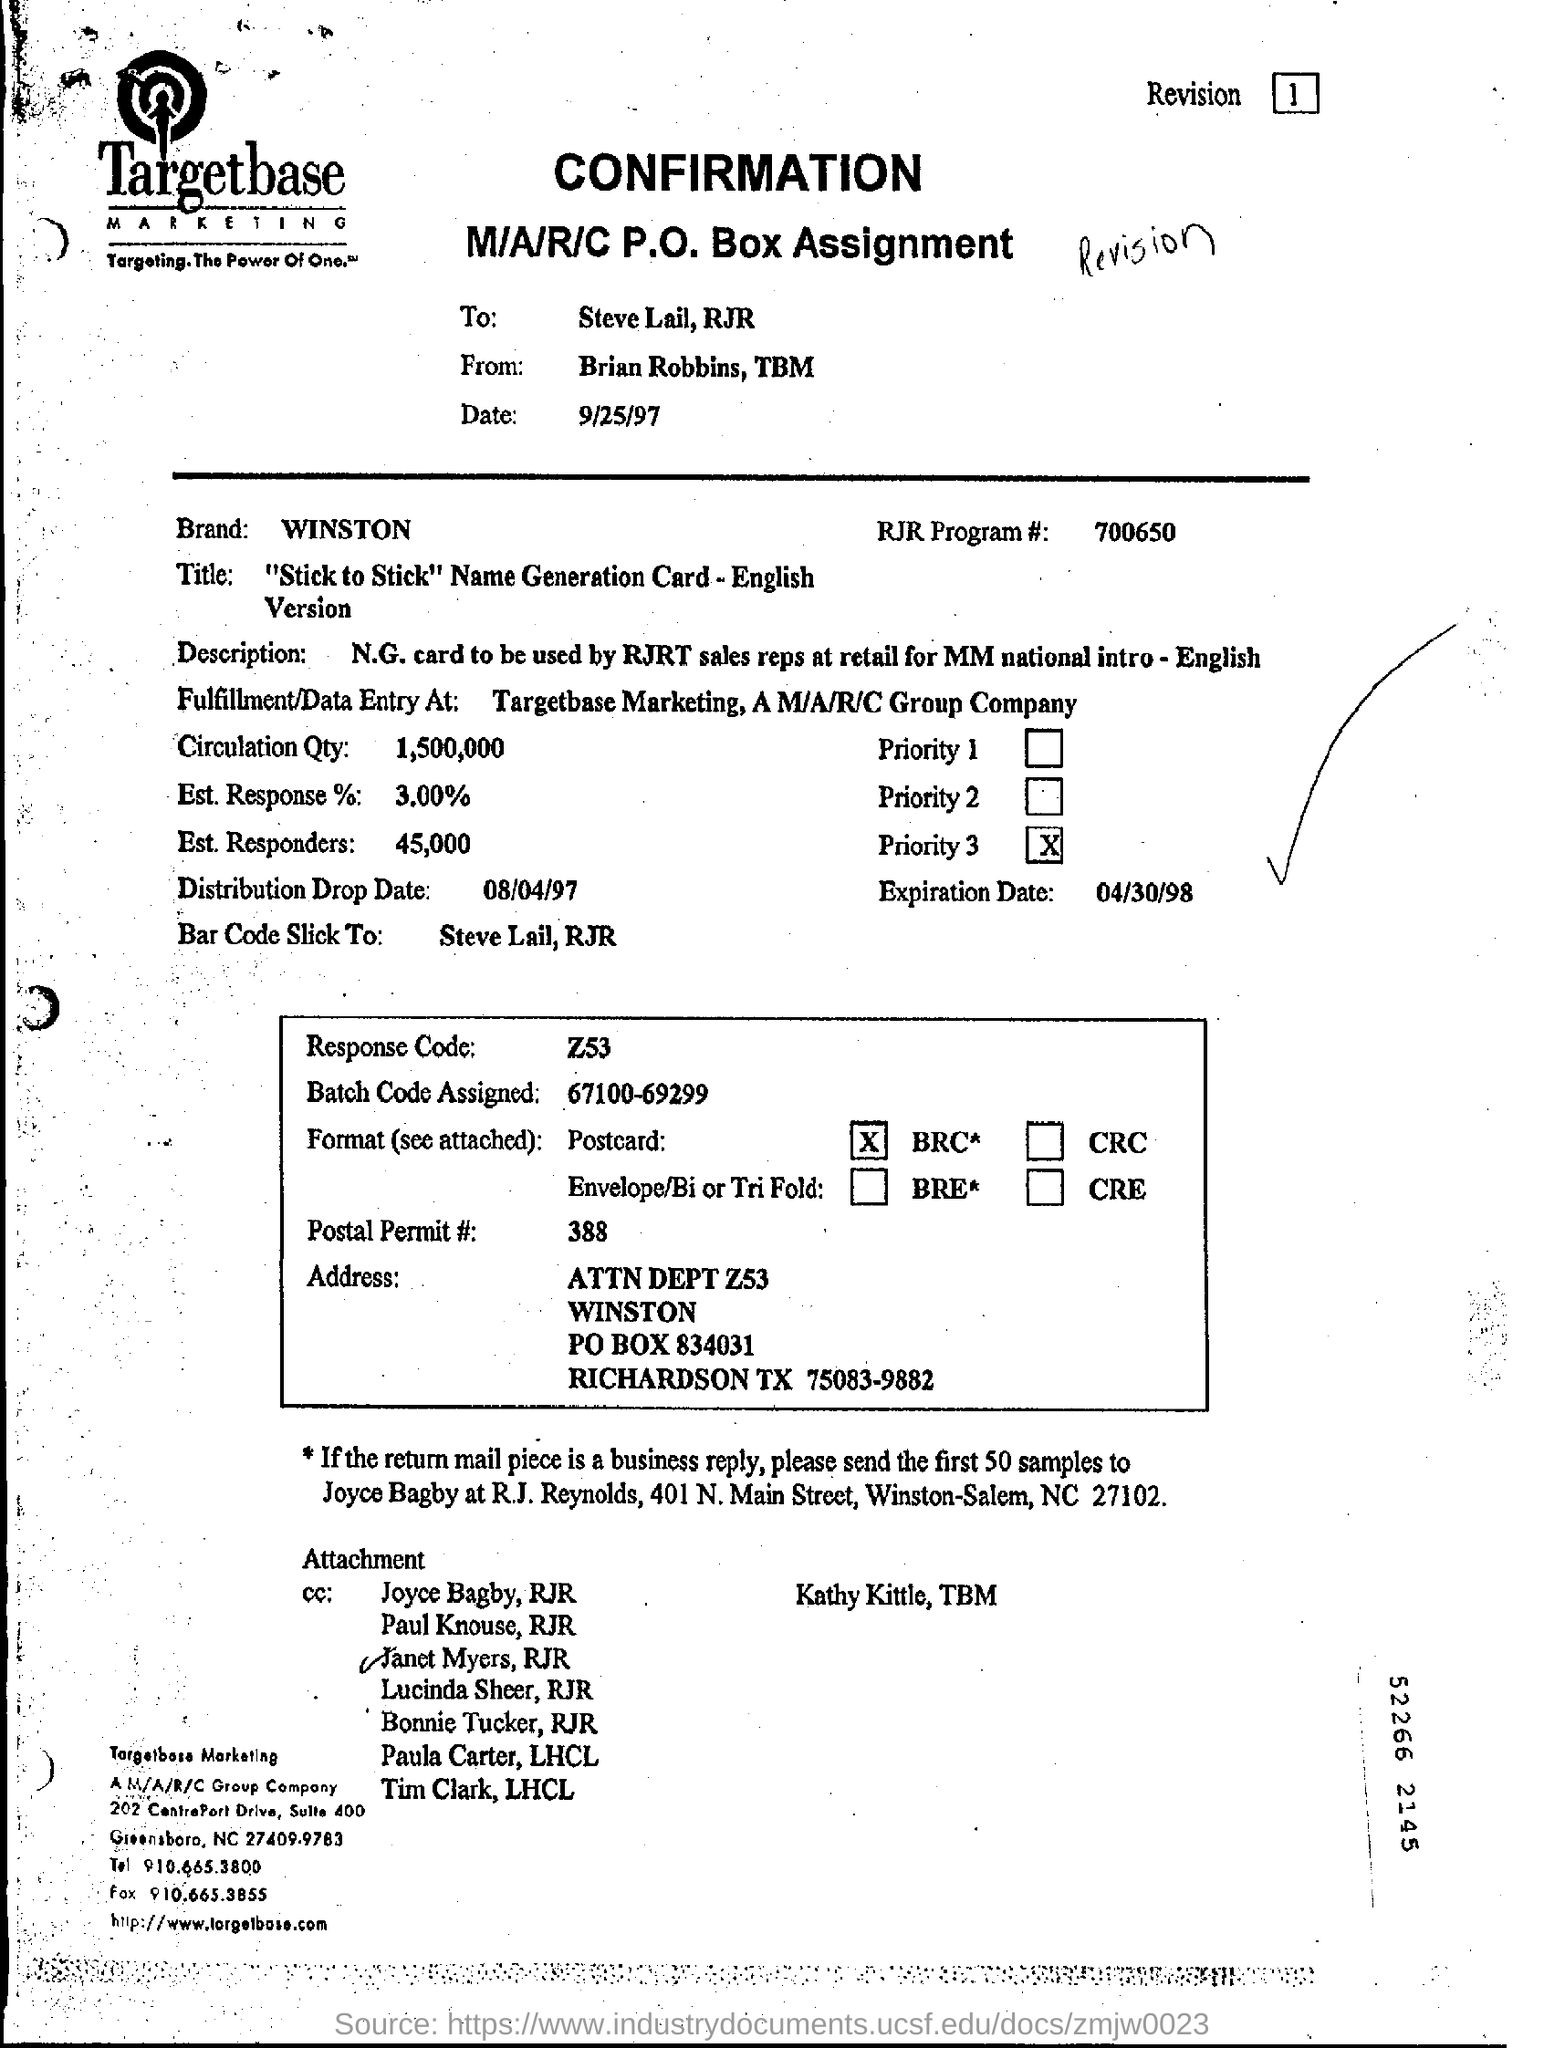Give some essential details in this illustration. The response code is Z53. The estimated response rate is 3.00%. The sender of the confirmation from Targetbase is Brian Robbins. 